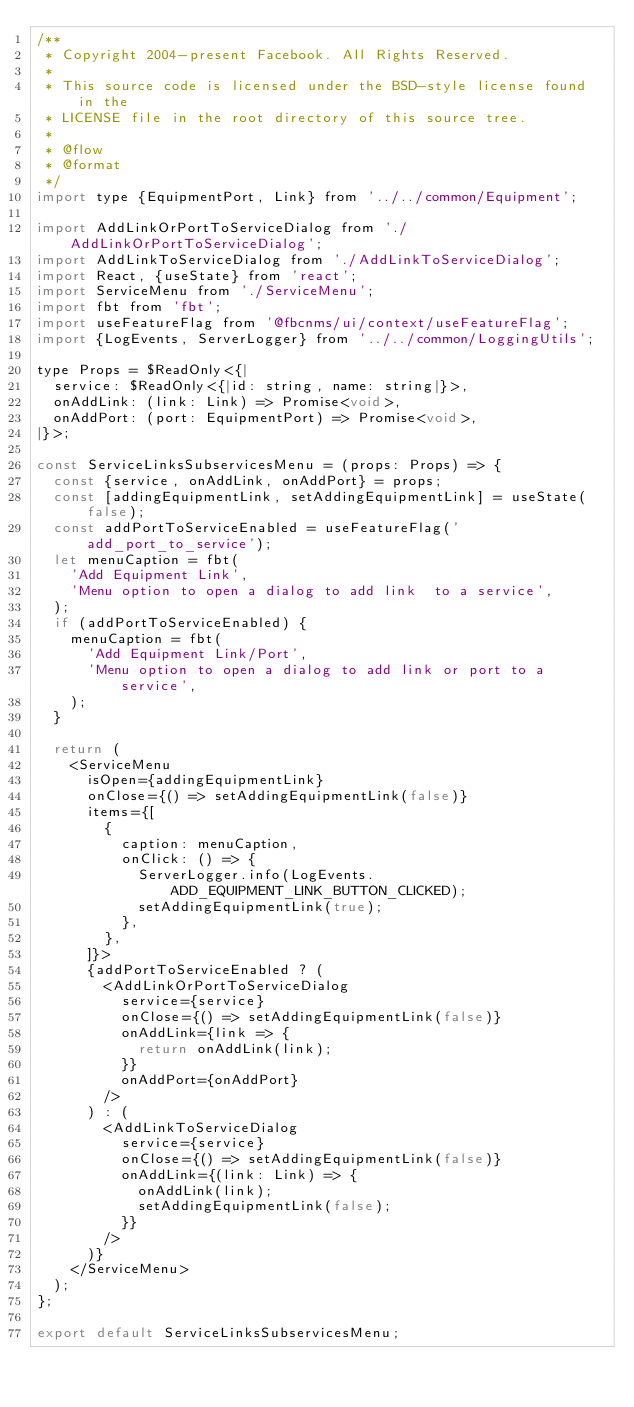Convert code to text. <code><loc_0><loc_0><loc_500><loc_500><_JavaScript_>/**
 * Copyright 2004-present Facebook. All Rights Reserved.
 *
 * This source code is licensed under the BSD-style license found in the
 * LICENSE file in the root directory of this source tree.
 *
 * @flow
 * @format
 */
import type {EquipmentPort, Link} from '../../common/Equipment';

import AddLinkOrPortToServiceDialog from './AddLinkOrPortToServiceDialog';
import AddLinkToServiceDialog from './AddLinkToServiceDialog';
import React, {useState} from 'react';
import ServiceMenu from './ServiceMenu';
import fbt from 'fbt';
import useFeatureFlag from '@fbcnms/ui/context/useFeatureFlag';
import {LogEvents, ServerLogger} from '../../common/LoggingUtils';

type Props = $ReadOnly<{|
  service: $ReadOnly<{|id: string, name: string|}>,
  onAddLink: (link: Link) => Promise<void>,
  onAddPort: (port: EquipmentPort) => Promise<void>,
|}>;

const ServiceLinksSubservicesMenu = (props: Props) => {
  const {service, onAddLink, onAddPort} = props;
  const [addingEquipmentLink, setAddingEquipmentLink] = useState(false);
  const addPortToServiceEnabled = useFeatureFlag('add_port_to_service');
  let menuCaption = fbt(
    'Add Equipment Link',
    'Menu option to open a dialog to add link  to a service',
  );
  if (addPortToServiceEnabled) {
    menuCaption = fbt(
      'Add Equipment Link/Port',
      'Menu option to open a dialog to add link or port to a service',
    );
  }

  return (
    <ServiceMenu
      isOpen={addingEquipmentLink}
      onClose={() => setAddingEquipmentLink(false)}
      items={[
        {
          caption: menuCaption,
          onClick: () => {
            ServerLogger.info(LogEvents.ADD_EQUIPMENT_LINK_BUTTON_CLICKED);
            setAddingEquipmentLink(true);
          },
        },
      ]}>
      {addPortToServiceEnabled ? (
        <AddLinkOrPortToServiceDialog
          service={service}
          onClose={() => setAddingEquipmentLink(false)}
          onAddLink={link => {
            return onAddLink(link);
          }}
          onAddPort={onAddPort}
        />
      ) : (
        <AddLinkToServiceDialog
          service={service}
          onClose={() => setAddingEquipmentLink(false)}
          onAddLink={(link: Link) => {
            onAddLink(link);
            setAddingEquipmentLink(false);
          }}
        />
      )}
    </ServiceMenu>
  );
};

export default ServiceLinksSubservicesMenu;
</code> 